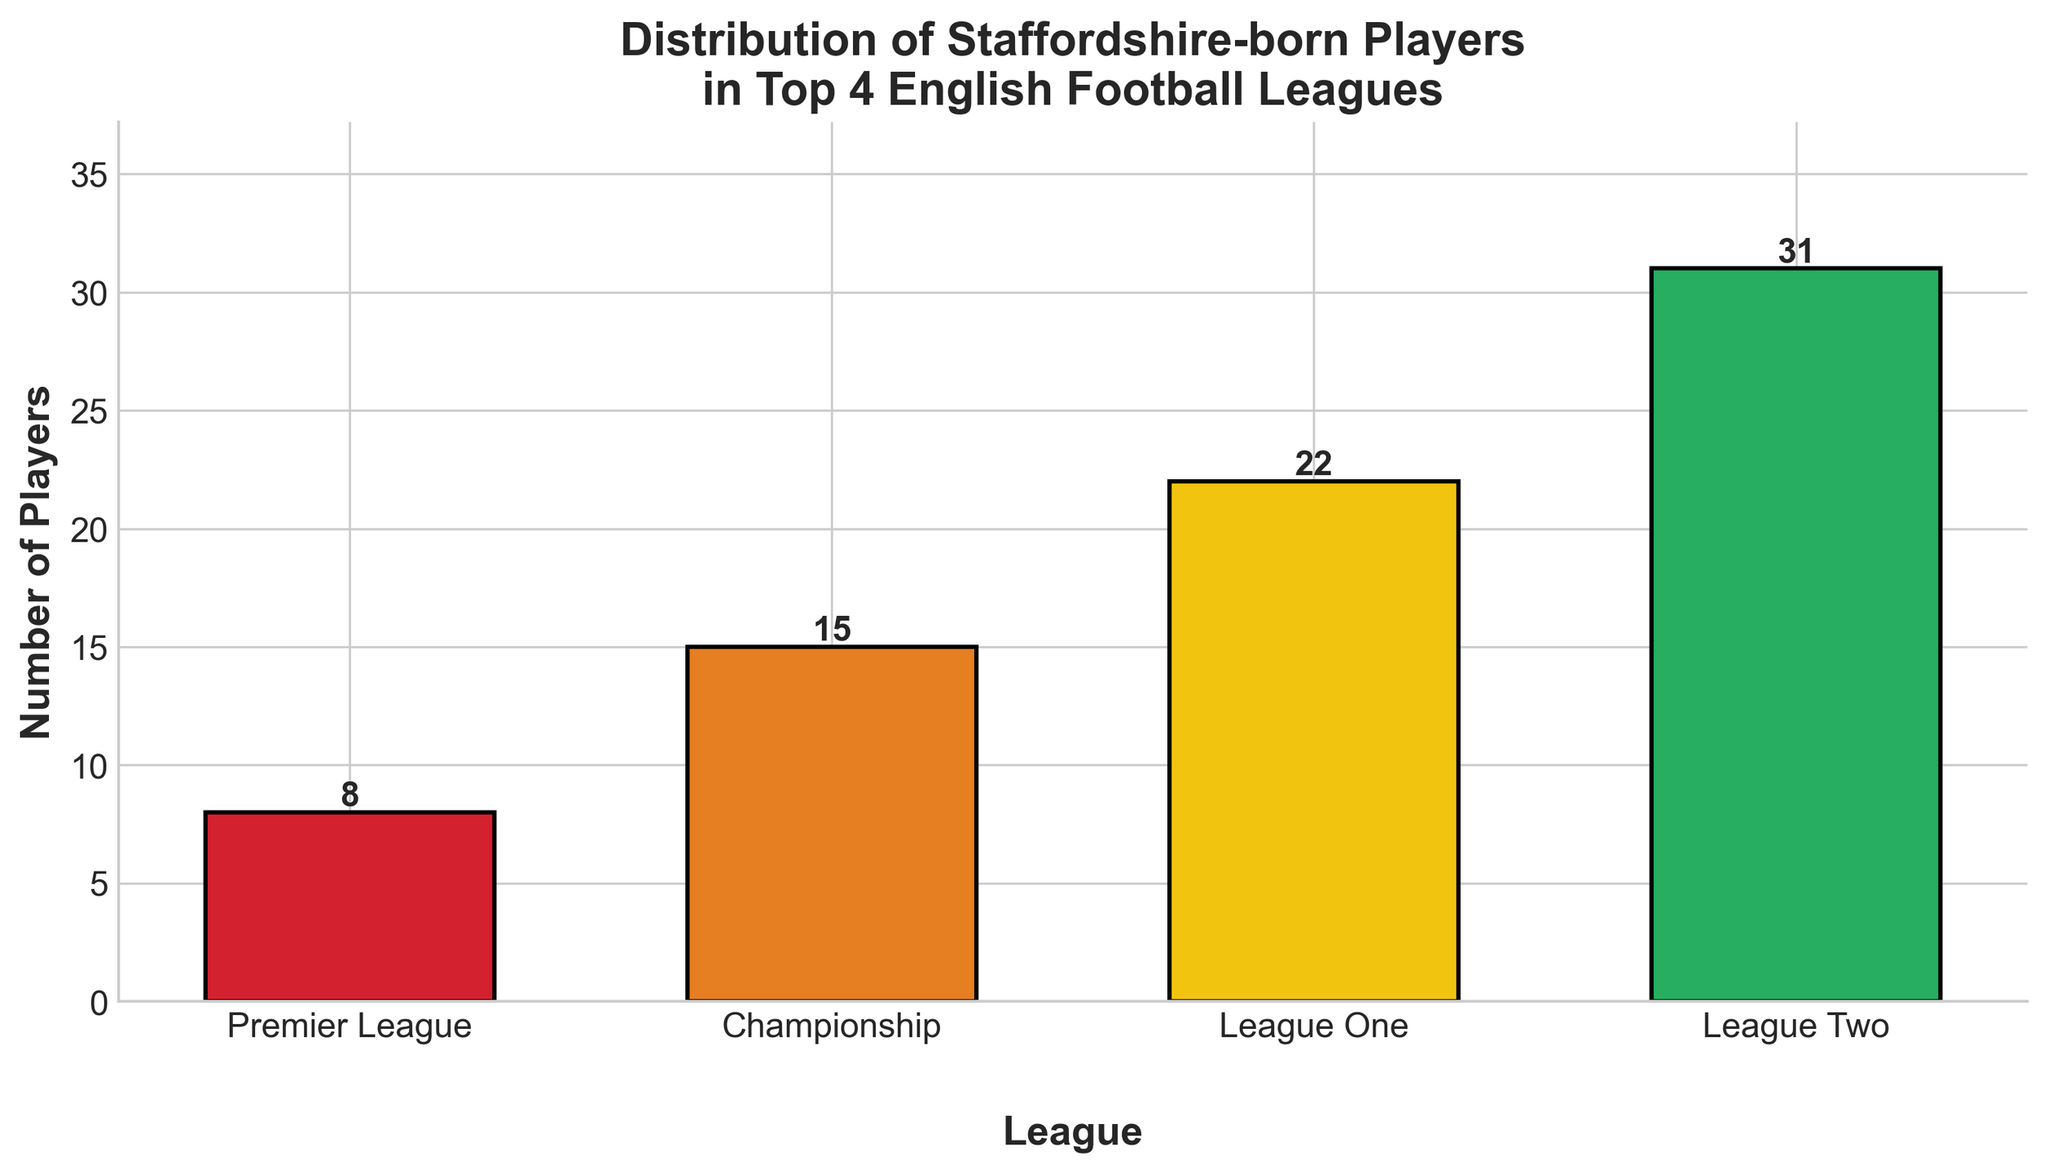Which league has the highest number of Staffordshire-born players? The bar for League Two is the tallest among all bars indicating that it has the highest number of Staffordshire-born players.
Answer: League Two What is the total number of Staffordshire-born players in all leagues combined? Sum the numbers of players in each league: 8 (Premier League) + 15 (Championship) + 22 (League One) + 31 (League Two) = 76.
Answer: 76 How many more Staffordshire-born players are in League Two compared to the Premier League? Subtract the number of Premier League players from the number of League Two players: 31 (League Two) - 8 (Premier League) = 23.
Answer: 23 What is the average number of Staffordshire-born players across the four leagues? Calculate the total number of players and divide by the number of leagues: 76 (Total players) / 4 (Leagues) = 19.
Answer: 19 In which league is the number of Staffordshire-born players closest to 20? The number of players in League One is 22, which is closest to 20 compared to other leagues.
Answer: League One How does the number of Staffordshire-born players in the Championship compare to those in League One? Compare the heights of the bars for Championship and League One: the Championship has 15 players and League One has 22 players, so League One has more.
Answer: League One What is the difference between the league with the most players and the league with the fewest players? Subtract the number of players in Premier League from the number of players in League Two: 31 (League Two) - 8 (Premier League) = 23.
Answer: 23 If you combine the number of Staffordshire-born players in League One and League Two, what percentage of the total players does this represent? Combine the players in League One and League Two: 22 (League One) + 31 (League Two) = 53. Total players is 76. Calculate the percentage: (53 / 76) * 100 ≈ 69.74%.
Answer: ~69.74% What color represents the Premier League in the bar chart? The Premier League bar is the first bar from the left and is colored in red.
Answer: Red 